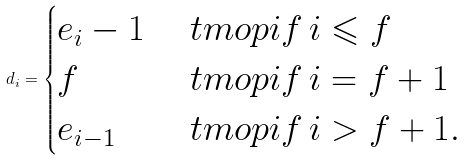Convert formula to latex. <formula><loc_0><loc_0><loc_500><loc_500>d _ { i } = \begin{cases} e _ { i } - 1 & \ t m o p { i f } \, i \leqslant f \\ f & \ t m o p { i f } \, i = f + 1 \\ e _ { i - 1 } & \ t m o p { i f } \, i > f + 1 . \end{cases}</formula> 